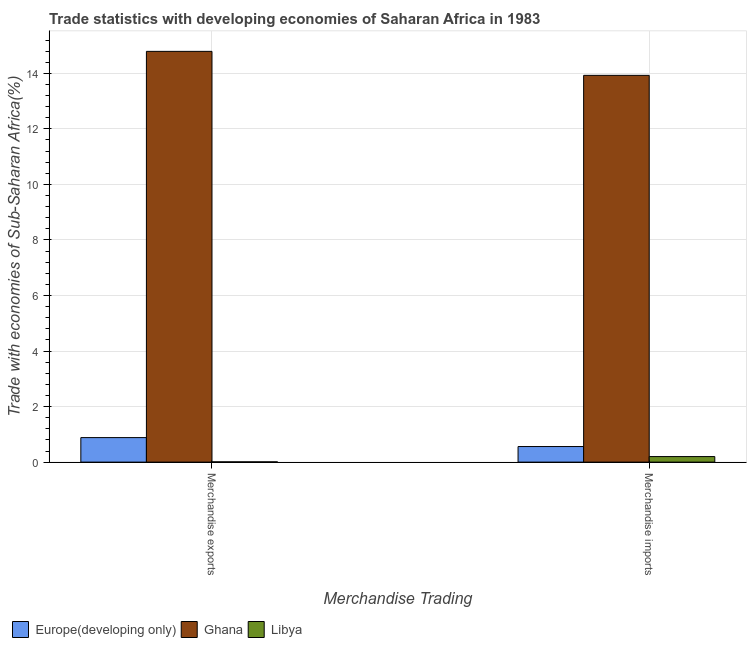How many different coloured bars are there?
Offer a terse response. 3. How many groups of bars are there?
Your answer should be compact. 2. How many bars are there on the 2nd tick from the left?
Your answer should be very brief. 3. What is the label of the 1st group of bars from the left?
Give a very brief answer. Merchandise exports. What is the merchandise exports in Ghana?
Offer a very short reply. 14.79. Across all countries, what is the maximum merchandise exports?
Your answer should be very brief. 14.79. Across all countries, what is the minimum merchandise exports?
Keep it short and to the point. 0.01. In which country was the merchandise imports minimum?
Provide a succinct answer. Libya. What is the total merchandise imports in the graph?
Your response must be concise. 14.69. What is the difference between the merchandise exports in Europe(developing only) and that in Ghana?
Keep it short and to the point. -13.91. What is the difference between the merchandise exports in Ghana and the merchandise imports in Libya?
Give a very brief answer. 14.59. What is the average merchandise exports per country?
Make the answer very short. 5.23. What is the difference between the merchandise imports and merchandise exports in Europe(developing only)?
Your response must be concise. -0.32. In how many countries, is the merchandise exports greater than 12 %?
Your answer should be compact. 1. What is the ratio of the merchandise imports in Libya to that in Europe(developing only)?
Make the answer very short. 0.36. Is the merchandise imports in Ghana less than that in Europe(developing only)?
Keep it short and to the point. No. How many bars are there?
Ensure brevity in your answer.  6. How many countries are there in the graph?
Make the answer very short. 3. How many legend labels are there?
Make the answer very short. 3. What is the title of the graph?
Provide a short and direct response. Trade statistics with developing economies of Saharan Africa in 1983. What is the label or title of the X-axis?
Ensure brevity in your answer.  Merchandise Trading. What is the label or title of the Y-axis?
Keep it short and to the point. Trade with economies of Sub-Saharan Africa(%). What is the Trade with economies of Sub-Saharan Africa(%) in Europe(developing only) in Merchandise exports?
Give a very brief answer. 0.88. What is the Trade with economies of Sub-Saharan Africa(%) of Ghana in Merchandise exports?
Provide a succinct answer. 14.79. What is the Trade with economies of Sub-Saharan Africa(%) in Libya in Merchandise exports?
Your answer should be compact. 0.01. What is the Trade with economies of Sub-Saharan Africa(%) in Europe(developing only) in Merchandise imports?
Ensure brevity in your answer.  0.56. What is the Trade with economies of Sub-Saharan Africa(%) in Ghana in Merchandise imports?
Offer a very short reply. 13.93. What is the Trade with economies of Sub-Saharan Africa(%) in Libya in Merchandise imports?
Provide a succinct answer. 0.2. Across all Merchandise Trading, what is the maximum Trade with economies of Sub-Saharan Africa(%) of Europe(developing only)?
Your answer should be very brief. 0.88. Across all Merchandise Trading, what is the maximum Trade with economies of Sub-Saharan Africa(%) of Ghana?
Offer a terse response. 14.79. Across all Merchandise Trading, what is the maximum Trade with economies of Sub-Saharan Africa(%) in Libya?
Your response must be concise. 0.2. Across all Merchandise Trading, what is the minimum Trade with economies of Sub-Saharan Africa(%) of Europe(developing only)?
Offer a very short reply. 0.56. Across all Merchandise Trading, what is the minimum Trade with economies of Sub-Saharan Africa(%) in Ghana?
Ensure brevity in your answer.  13.93. Across all Merchandise Trading, what is the minimum Trade with economies of Sub-Saharan Africa(%) in Libya?
Give a very brief answer. 0.01. What is the total Trade with economies of Sub-Saharan Africa(%) of Europe(developing only) in the graph?
Your answer should be very brief. 1.44. What is the total Trade with economies of Sub-Saharan Africa(%) in Ghana in the graph?
Provide a short and direct response. 28.72. What is the total Trade with economies of Sub-Saharan Africa(%) of Libya in the graph?
Offer a very short reply. 0.21. What is the difference between the Trade with economies of Sub-Saharan Africa(%) in Europe(developing only) in Merchandise exports and that in Merchandise imports?
Your answer should be compact. 0.32. What is the difference between the Trade with economies of Sub-Saharan Africa(%) of Ghana in Merchandise exports and that in Merchandise imports?
Make the answer very short. 0.86. What is the difference between the Trade with economies of Sub-Saharan Africa(%) of Libya in Merchandise exports and that in Merchandise imports?
Make the answer very short. -0.19. What is the difference between the Trade with economies of Sub-Saharan Africa(%) of Europe(developing only) in Merchandise exports and the Trade with economies of Sub-Saharan Africa(%) of Ghana in Merchandise imports?
Your answer should be very brief. -13.04. What is the difference between the Trade with economies of Sub-Saharan Africa(%) in Europe(developing only) in Merchandise exports and the Trade with economies of Sub-Saharan Africa(%) in Libya in Merchandise imports?
Keep it short and to the point. 0.68. What is the difference between the Trade with economies of Sub-Saharan Africa(%) in Ghana in Merchandise exports and the Trade with economies of Sub-Saharan Africa(%) in Libya in Merchandise imports?
Give a very brief answer. 14.59. What is the average Trade with economies of Sub-Saharan Africa(%) in Europe(developing only) per Merchandise Trading?
Your answer should be very brief. 0.72. What is the average Trade with economies of Sub-Saharan Africa(%) of Ghana per Merchandise Trading?
Make the answer very short. 14.36. What is the average Trade with economies of Sub-Saharan Africa(%) in Libya per Merchandise Trading?
Ensure brevity in your answer.  0.1. What is the difference between the Trade with economies of Sub-Saharan Africa(%) of Europe(developing only) and Trade with economies of Sub-Saharan Africa(%) of Ghana in Merchandise exports?
Your answer should be very brief. -13.91. What is the difference between the Trade with economies of Sub-Saharan Africa(%) in Europe(developing only) and Trade with economies of Sub-Saharan Africa(%) in Libya in Merchandise exports?
Keep it short and to the point. 0.87. What is the difference between the Trade with economies of Sub-Saharan Africa(%) in Ghana and Trade with economies of Sub-Saharan Africa(%) in Libya in Merchandise exports?
Your answer should be very brief. 14.78. What is the difference between the Trade with economies of Sub-Saharan Africa(%) in Europe(developing only) and Trade with economies of Sub-Saharan Africa(%) in Ghana in Merchandise imports?
Provide a succinct answer. -13.37. What is the difference between the Trade with economies of Sub-Saharan Africa(%) in Europe(developing only) and Trade with economies of Sub-Saharan Africa(%) in Libya in Merchandise imports?
Give a very brief answer. 0.36. What is the difference between the Trade with economies of Sub-Saharan Africa(%) of Ghana and Trade with economies of Sub-Saharan Africa(%) of Libya in Merchandise imports?
Your answer should be very brief. 13.73. What is the ratio of the Trade with economies of Sub-Saharan Africa(%) in Europe(developing only) in Merchandise exports to that in Merchandise imports?
Offer a very short reply. 1.57. What is the ratio of the Trade with economies of Sub-Saharan Africa(%) in Ghana in Merchandise exports to that in Merchandise imports?
Offer a very short reply. 1.06. What is the ratio of the Trade with economies of Sub-Saharan Africa(%) of Libya in Merchandise exports to that in Merchandise imports?
Provide a short and direct response. 0.05. What is the difference between the highest and the second highest Trade with economies of Sub-Saharan Africa(%) of Europe(developing only)?
Make the answer very short. 0.32. What is the difference between the highest and the second highest Trade with economies of Sub-Saharan Africa(%) of Ghana?
Provide a succinct answer. 0.86. What is the difference between the highest and the second highest Trade with economies of Sub-Saharan Africa(%) in Libya?
Your answer should be very brief. 0.19. What is the difference between the highest and the lowest Trade with economies of Sub-Saharan Africa(%) of Europe(developing only)?
Make the answer very short. 0.32. What is the difference between the highest and the lowest Trade with economies of Sub-Saharan Africa(%) of Ghana?
Make the answer very short. 0.86. What is the difference between the highest and the lowest Trade with economies of Sub-Saharan Africa(%) in Libya?
Make the answer very short. 0.19. 